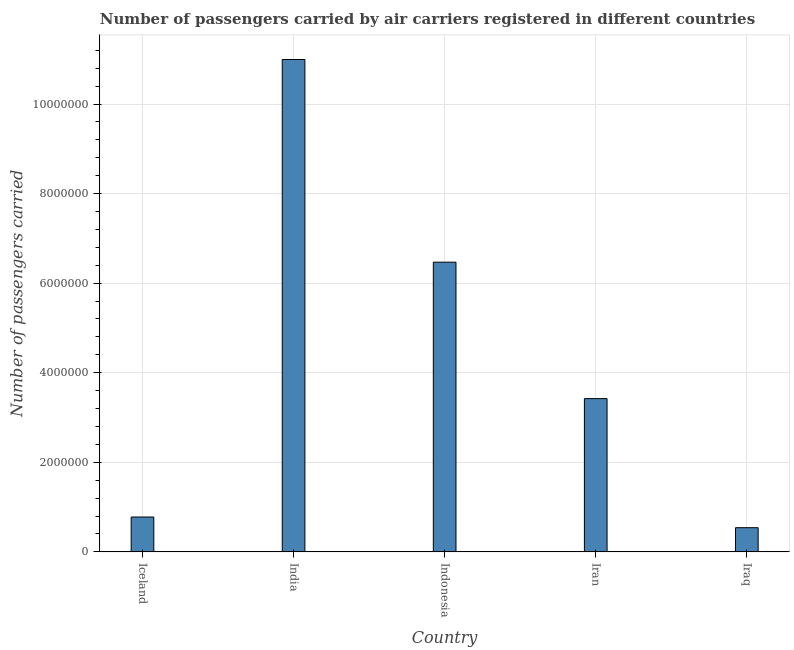Does the graph contain any zero values?
Offer a very short reply. No. Does the graph contain grids?
Ensure brevity in your answer.  Yes. What is the title of the graph?
Your response must be concise. Number of passengers carried by air carriers registered in different countries. What is the label or title of the Y-axis?
Provide a succinct answer. Number of passengers carried. What is the number of passengers carried in Iraq?
Keep it short and to the point. 5.40e+05. Across all countries, what is the maximum number of passengers carried?
Provide a short and direct response. 1.10e+07. Across all countries, what is the minimum number of passengers carried?
Provide a succinct answer. 5.40e+05. In which country was the number of passengers carried minimum?
Offer a very short reply. Iraq. What is the sum of the number of passengers carried?
Make the answer very short. 2.22e+07. What is the difference between the number of passengers carried in India and Iraq?
Provide a short and direct response. 1.05e+07. What is the average number of passengers carried per country?
Provide a short and direct response. 4.44e+06. What is the median number of passengers carried?
Provide a short and direct response. 3.42e+06. What is the ratio of the number of passengers carried in India to that in Iraq?
Give a very brief answer. 20.36. Is the difference between the number of passengers carried in India and Indonesia greater than the difference between any two countries?
Provide a succinct answer. No. What is the difference between the highest and the second highest number of passengers carried?
Give a very brief answer. 4.53e+06. What is the difference between the highest and the lowest number of passengers carried?
Your answer should be very brief. 1.05e+07. In how many countries, is the number of passengers carried greater than the average number of passengers carried taken over all countries?
Your answer should be compact. 2. Are all the bars in the graph horizontal?
Provide a succinct answer. No. What is the difference between two consecutive major ticks on the Y-axis?
Make the answer very short. 2.00e+06. What is the Number of passengers carried in Iceland?
Your answer should be compact. 7.78e+05. What is the Number of passengers carried of India?
Your answer should be compact. 1.10e+07. What is the Number of passengers carried in Indonesia?
Your answer should be compact. 6.47e+06. What is the Number of passengers carried in Iran?
Your answer should be very brief. 3.42e+06. What is the Number of passengers carried in Iraq?
Provide a succinct answer. 5.40e+05. What is the difference between the Number of passengers carried in Iceland and India?
Provide a succinct answer. -1.02e+07. What is the difference between the Number of passengers carried in Iceland and Indonesia?
Provide a short and direct response. -5.69e+06. What is the difference between the Number of passengers carried in Iceland and Iran?
Provide a short and direct response. -2.64e+06. What is the difference between the Number of passengers carried in Iceland and Iraq?
Offer a terse response. 2.38e+05. What is the difference between the Number of passengers carried in India and Indonesia?
Offer a terse response. 4.53e+06. What is the difference between the Number of passengers carried in India and Iran?
Keep it short and to the point. 7.57e+06. What is the difference between the Number of passengers carried in India and Iraq?
Provide a short and direct response. 1.05e+07. What is the difference between the Number of passengers carried in Indonesia and Iran?
Keep it short and to the point. 3.05e+06. What is the difference between the Number of passengers carried in Indonesia and Iraq?
Provide a succinct answer. 5.93e+06. What is the difference between the Number of passengers carried in Iran and Iraq?
Give a very brief answer. 2.88e+06. What is the ratio of the Number of passengers carried in Iceland to that in India?
Your response must be concise. 0.07. What is the ratio of the Number of passengers carried in Iceland to that in Indonesia?
Make the answer very short. 0.12. What is the ratio of the Number of passengers carried in Iceland to that in Iran?
Make the answer very short. 0.23. What is the ratio of the Number of passengers carried in Iceland to that in Iraq?
Ensure brevity in your answer.  1.44. What is the ratio of the Number of passengers carried in India to that in Iran?
Keep it short and to the point. 3.21. What is the ratio of the Number of passengers carried in India to that in Iraq?
Offer a very short reply. 20.36. What is the ratio of the Number of passengers carried in Indonesia to that in Iran?
Make the answer very short. 1.89. What is the ratio of the Number of passengers carried in Indonesia to that in Iraq?
Make the answer very short. 11.98. What is the ratio of the Number of passengers carried in Iran to that in Iraq?
Give a very brief answer. 6.34. 